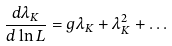<formula> <loc_0><loc_0><loc_500><loc_500>\frac { d \lambda _ { K } } { d \ln L } = g \lambda _ { K } + \lambda _ { K } ^ { 2 } + \dots</formula> 